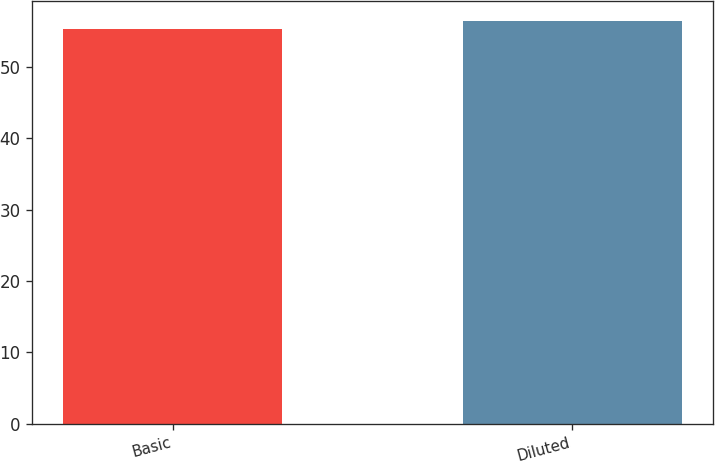<chart> <loc_0><loc_0><loc_500><loc_500><bar_chart><fcel>Basic<fcel>Diluted<nl><fcel>55.3<fcel>56.4<nl></chart> 